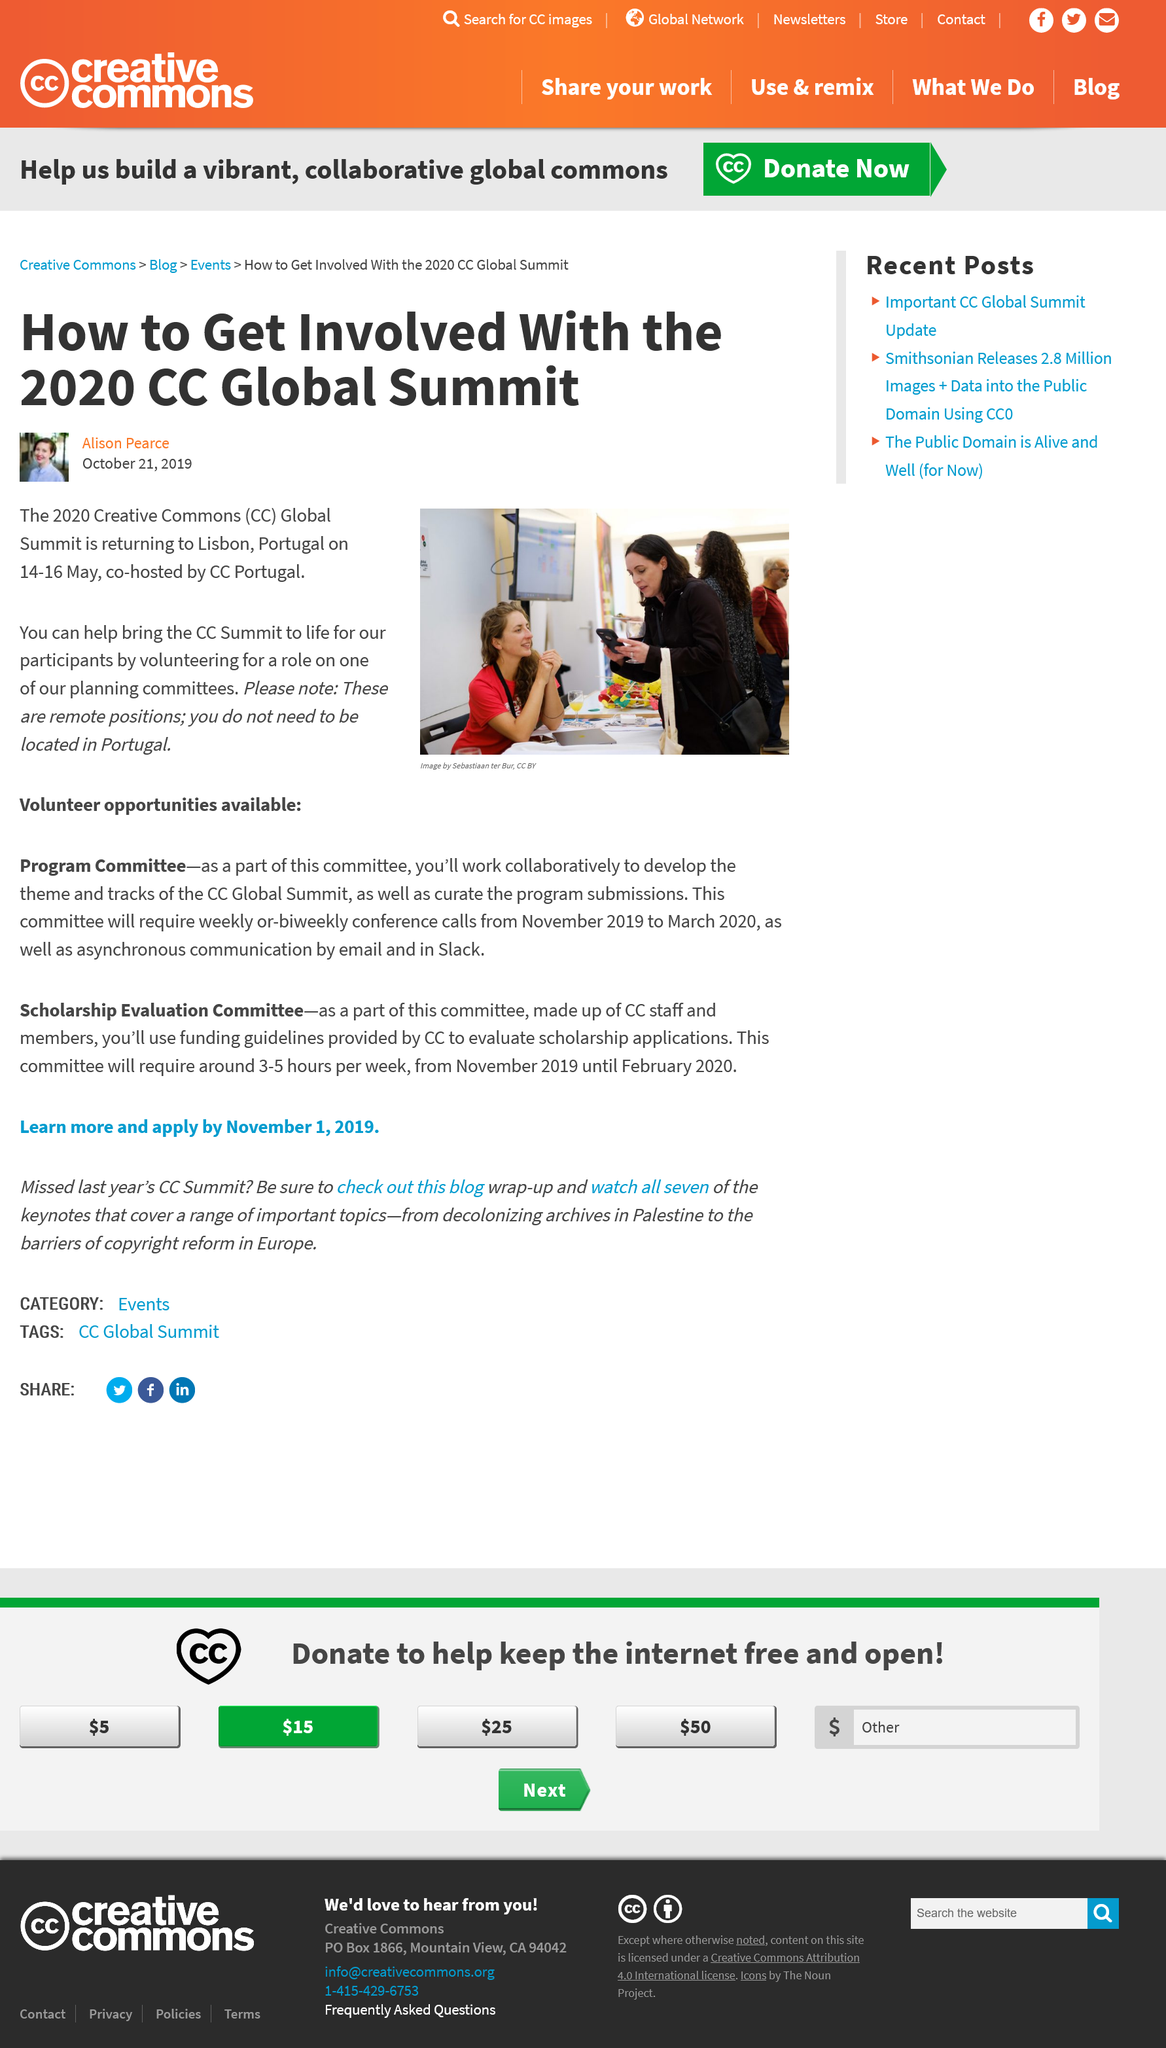Draw attention to some important aspects in this diagram. It is not necessary to reside in Portugal in order to volunteer for the planning committees, as these positions are remote. I am capable of assisting in the success of the 2020 CC Global Summit by volunteering to serve on a planning committee and contributing to the planning and execution of the event. The CC Global Summit 2020 will be held in Lisbon, Portugal. 